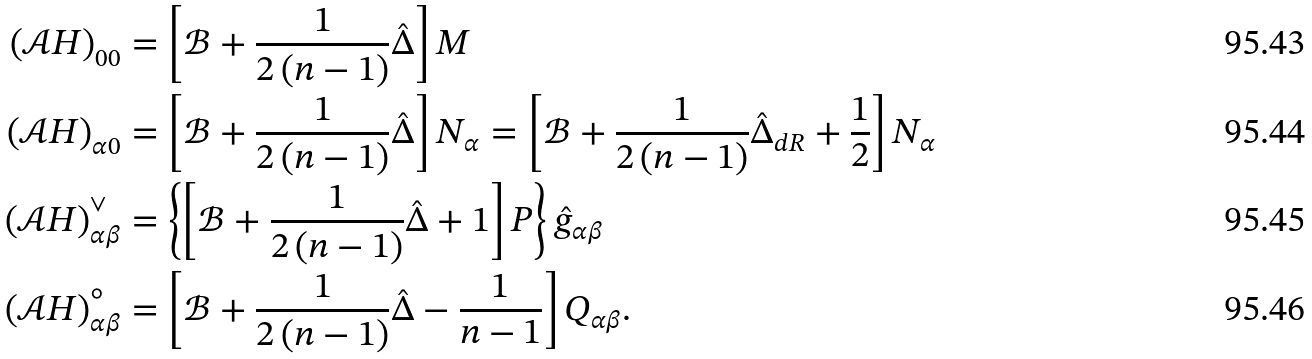Convert formula to latex. <formula><loc_0><loc_0><loc_500><loc_500>\left ( \mathcal { A } H \right ) _ { 0 0 } & = \left [ \mathcal { B } + \frac { 1 } { 2 \left ( n - 1 \right ) } \hat { \Delta } \right ] M \\ \left ( \mathcal { A } H \right ) _ { \alpha 0 } & = \left [ \mathcal { B } + \frac { 1 } { 2 \left ( n - 1 \right ) } \hat { \Delta } \right ] N _ { \alpha } = \left [ \mathcal { B } + \frac { 1 } { 2 \left ( n - 1 \right ) } \hat { \Delta } _ { d R } + \frac { 1 } { 2 } \right ] N _ { \alpha } \\ \left ( \mathcal { A } H \right ) _ { \alpha \beta } ^ { \vee } & = \left \{ \left [ \mathcal { B } + \frac { 1 } { 2 \left ( n - 1 \right ) } \hat { \Delta } + 1 \right ] P \right \} \hat { g } _ { \alpha \beta } \\ \left ( \mathcal { A } H \right ) _ { \alpha \beta } ^ { \circ } & = \left [ \mathcal { B } + \frac { 1 } { 2 \left ( n - 1 \right ) } \hat { \Delta } - \frac { 1 } { n - 1 } \right ] Q _ { \alpha \beta } .</formula> 